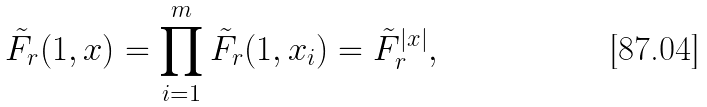Convert formula to latex. <formula><loc_0><loc_0><loc_500><loc_500>\tilde { F } _ { r } ( 1 , x ) = \prod _ { i = 1 } ^ { m } \tilde { F } _ { r } ( 1 , x _ { i } ) = \tilde { F } _ { r } ^ { | x | } ,</formula> 